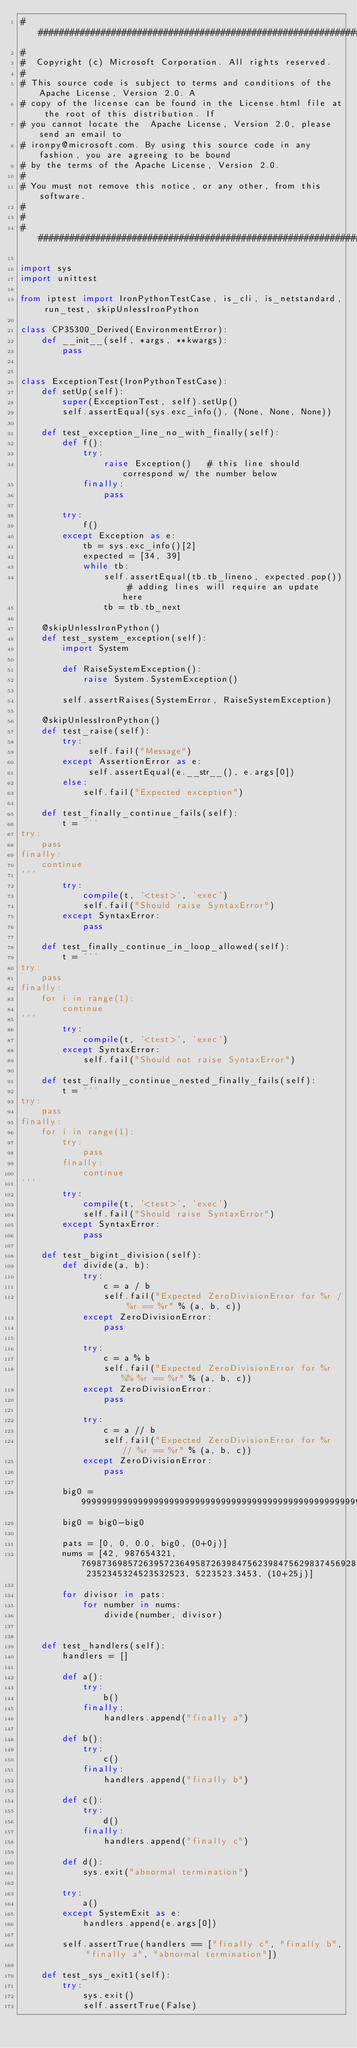<code> <loc_0><loc_0><loc_500><loc_500><_Python_>#####################################################################################
#
#  Copyright (c) Microsoft Corporation. All rights reserved.
#
# This source code is subject to terms and conditions of the Apache License, Version 2.0. A
# copy of the license can be found in the License.html file at the root of this distribution. If
# you cannot locate the  Apache License, Version 2.0, please send an email to
# ironpy@microsoft.com. By using this source code in any fashion, you are agreeing to be bound
# by the terms of the Apache License, Version 2.0.
#
# You must not remove this notice, or any other, from this software.
#
#
#####################################################################################

import sys
import unittest

from iptest import IronPythonTestCase, is_cli, is_netstandard, run_test, skipUnlessIronPython

class CP35300_Derived(EnvironmentError):
    def __init__(self, *args, **kwargs):
        pass


class ExceptionTest(IronPythonTestCase):
    def setUp(self):
        super(ExceptionTest, self).setUp()
        self.assertEqual(sys.exc_info(), (None, None, None))

    def test_exception_line_no_with_finally(self):
        def f():
            try:
                raise Exception()   # this line should correspond w/ the number below
            finally:
                pass
        
        try:
            f()
        except Exception as e:
            tb = sys.exc_info()[2]
            expected = [34, 39]
            while tb:
                self.assertEqual(tb.tb_lineno, expected.pop()) # adding lines will require an update here
                tb = tb.tb_next
            
    @skipUnlessIronPython()
    def test_system_exception(self):
        import System
        
        def RaiseSystemException():
            raise System.SystemException()

        self.assertRaises(SystemError, RaiseSystemException)

    @skipUnlessIronPython()
    def test_raise(self):
        try:
             self.fail("Message")
        except AssertionError as e:
             self.assertEqual(e.__str__(), e.args[0])
        else:
            self.fail("Expected exception")

    def test_finally_continue_fails(self):
        t = '''
try:
    pass
finally:
    continue
'''
        try:
            compile(t, '<test>', 'exec')
            self.fail("Should raise SyntaxError")
        except SyntaxError:
            pass

    def test_finally_continue_in_loop_allowed(self):
        t = '''
try:
    pass
finally:
    for i in range(1):
        continue
'''
        try:
            compile(t, '<test>', 'exec')
        except SyntaxError:
            self.fail("Should not raise SyntaxError")

    def test_finally_continue_nested_finally_fails(self):
        t = '''
try:
    pass
finally:
    for i in range(1):
        try:
            pass
        finally:
            continue
'''
        try:
            compile(t, '<test>', 'exec')
            self.fail("Should raise SyntaxError")
        except SyntaxError:
            pass

    def test_bigint_division(self):
        def divide(a, b):
            try:
                c = a / b
                self.fail("Expected ZeroDivisionError for %r / %r == %r" % (a, b, c))
            except ZeroDivisionError:
                pass

            try:
                c = a % b
                self.fail("Expected ZeroDivisionError for %r %% %r == %r" % (a, b, c))
            except ZeroDivisionError:
                pass

            try:
                c = a // b
                self.fail("Expected ZeroDivisionError for %r // %r == %r" % (a, b, c))
            except ZeroDivisionError:
                pass

        big0 = 9999999999999999999999999999999999999999999999999999999999999999999999
        big0 = big0-big0

        pats = [0, 0, 0.0, big0, (0+0j)]
        nums = [42, 987654321, 7698736985726395723649587263984756239847562983745692837465928374569283746592837465923, 2352345324523532523, 5223523.3453, (10+25j)]

        for divisor in pats:
            for number in nums:
                divide(number, divisor)


    def test_handlers(self):
        handlers = []

        def a():
            try:
                b()
            finally:
                handlers.append("finally a")

        def b():
            try:
                c()
            finally:
                handlers.append("finally b")

        def c():
            try:
                d()
            finally:
                handlers.append("finally c")

        def d():
            sys.exit("abnormal termination")

        try:
            a()
        except SystemExit as e:
            handlers.append(e.args[0])

        self.assertTrue(handlers == ["finally c", "finally b", "finally a", "abnormal termination"])

    def test_sys_exit1(self):
        try:
            sys.exit()
            self.assertTrue(False)</code> 